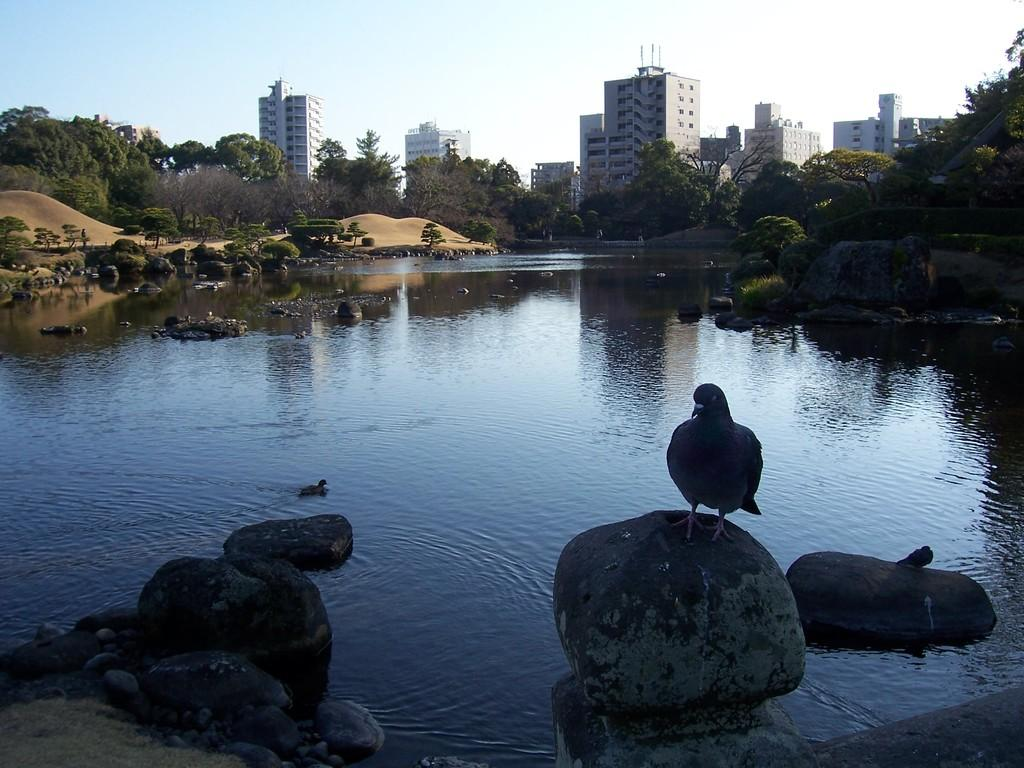What is the primary element present in the image? There is water in the image. What type of animals can be seen in the image? There are birds in the image. What other objects are present in the image? There are stones, trees, and buildings in the image. What is visible at the top of the image? The sky is visible at the top of the image. Can you see the kitten's hair in the image? There is no kitten or hair present in the image. How many drops of water are visible in the image? The image does not specify a specific number of water drops; it only shows that there is water present. 